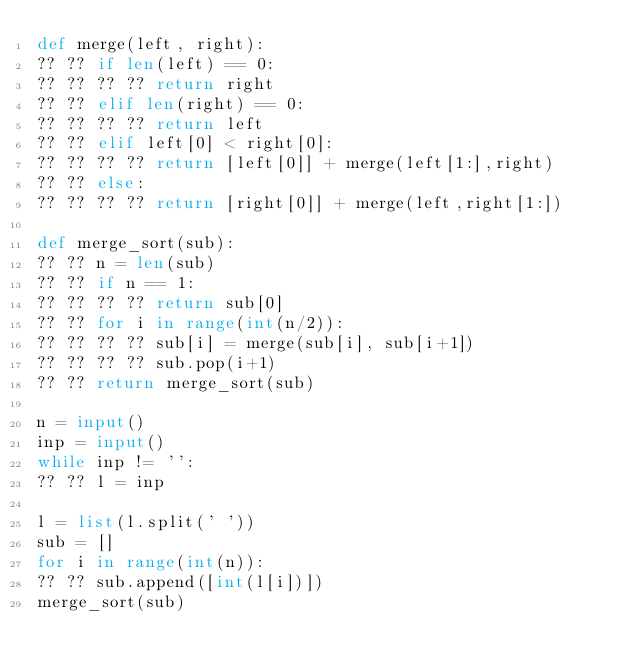Convert code to text. <code><loc_0><loc_0><loc_500><loc_500><_Python_>def merge(left, right):
?? ?? if len(left) == 0:
?? ?? ?? ?? return right
?? ?? elif len(right) == 0:
?? ?? ?? ?? return left
?? ?? elif left[0] < right[0]:
?? ?? ?? ?? return [left[0]] + merge(left[1:],right)
?? ?? else:
?? ?? ?? ?? return [right[0]] + merge(left,right[1:])

def merge_sort(sub):
?? ?? n = len(sub)
?? ?? if n == 1:
?? ?? ?? ?? return sub[0]
?? ?? for i in range(int(n/2)):
?? ?? ?? ?? sub[i] = merge(sub[i], sub[i+1])
?? ?? ?? ?? sub.pop(i+1)
?? ?? return merge_sort(sub)

n = input()
inp = input()
while inp != '':
?? ?? l = inp

l = list(l.split(' '))
sub = []
for i in range(int(n)):
?? ?? sub.append([int(l[i])])
merge_sort(sub)</code> 